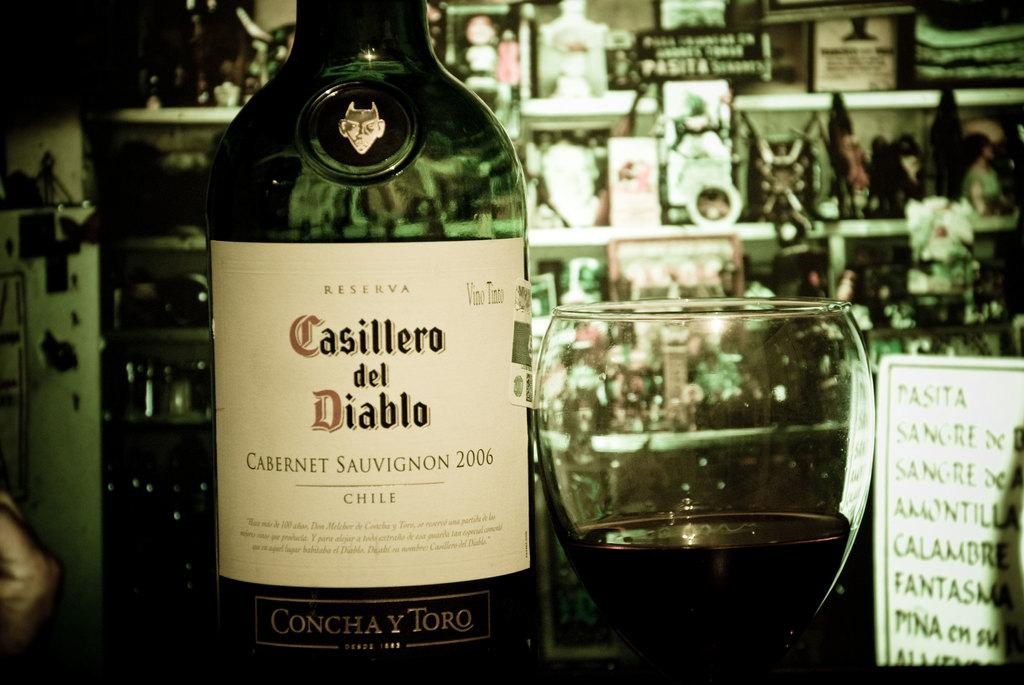What is the main object on the left side of the image? There is a wine bottle on the left side of the image. What is the main object on the right side of the image? There is a glass of wine on the right side of the image. Can you describe the positioning of the wine bottle and glass of wine in the image? The wine bottle is on the left side of the image, and the glass of wine is on the right side of the image. What type of science experiment is being conducted with the wine bottle and glass of wine in the image? There is no indication of a science experiment in the image; it simply shows a wine bottle and a glass of wine. Can you see a badge on the wine bottle or glass of wine in the image? There is no badge present on the wine bottle or glass of wine in the image. 